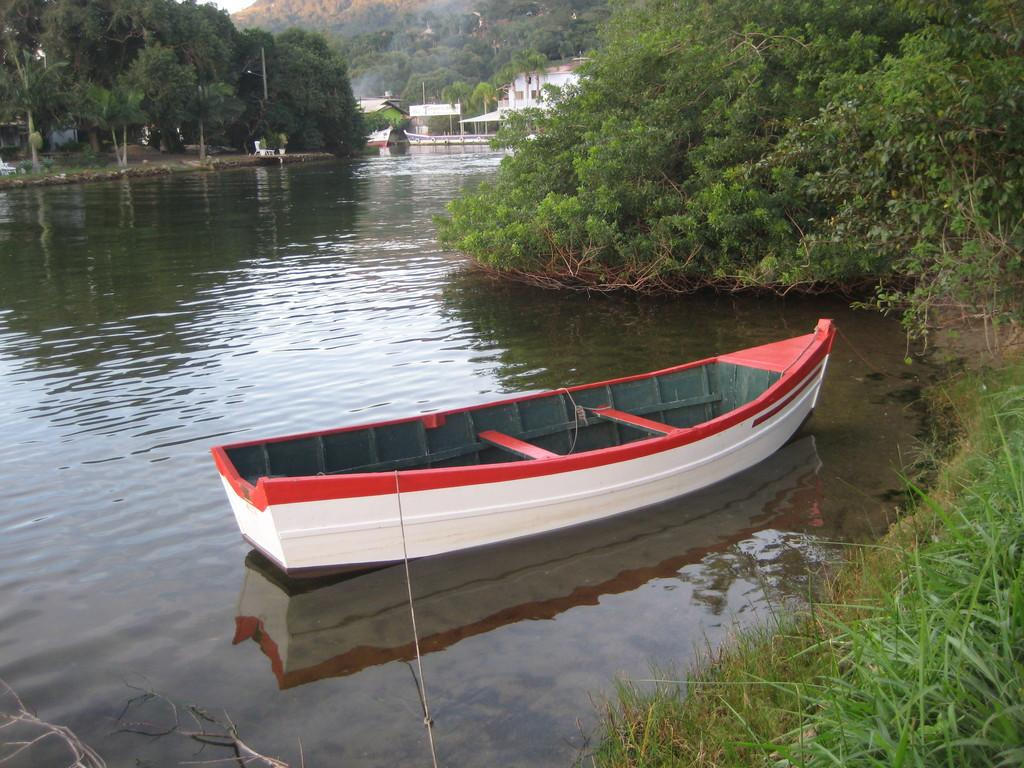What is the main subject of the image? There is a boat on the water in the image. What type of vegetation can be seen in the image? There is grass visible in the image, and there are also trees. What structures are visible in the background of the image? There are houses and a mountain in the background of the image. How many quarters can be seen on the boat in the image? There are no quarters visible on the boat in the image. What type of bead is being used as a decoration on the trees in the image? There are no beads present on the trees in the image. 